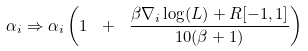Convert formula to latex. <formula><loc_0><loc_0><loc_500><loc_500>\alpha _ { i } \Rightarrow \alpha _ { i } \left ( 1 \ + \ \frac { \beta \nabla _ { i } \log ( L ) + R [ - 1 , 1 ] } { 1 0 ( \beta + 1 ) } \right )</formula> 